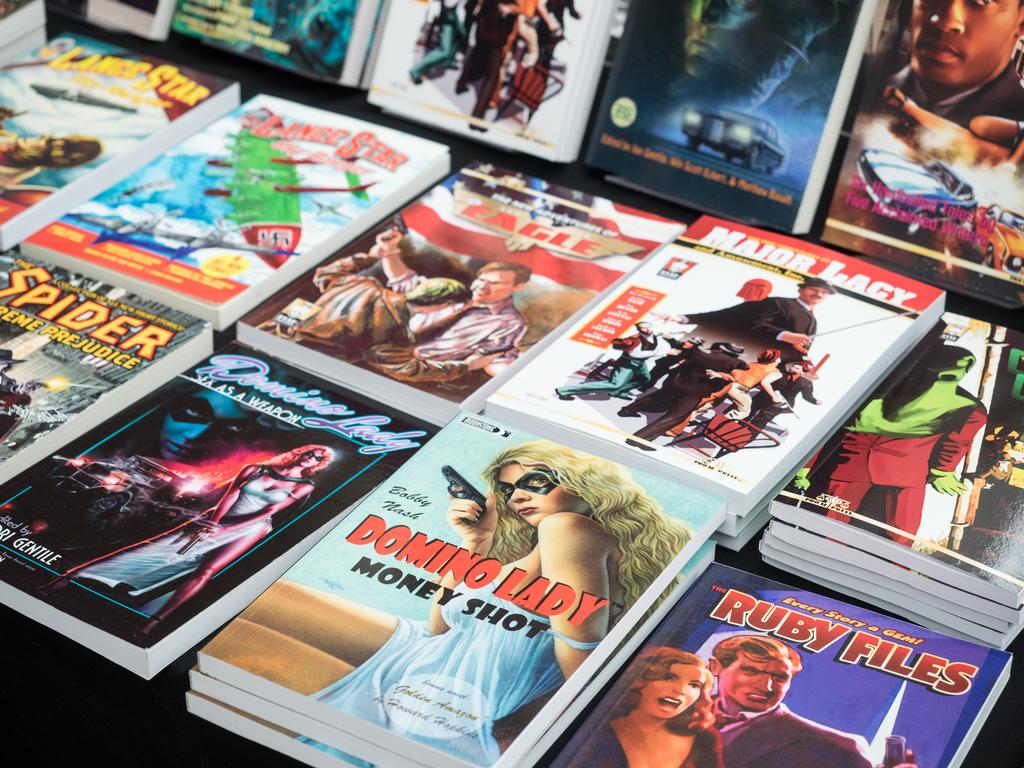<image>
Provide a brief description of the given image. a table of books with one of them titled 'ruby files' 